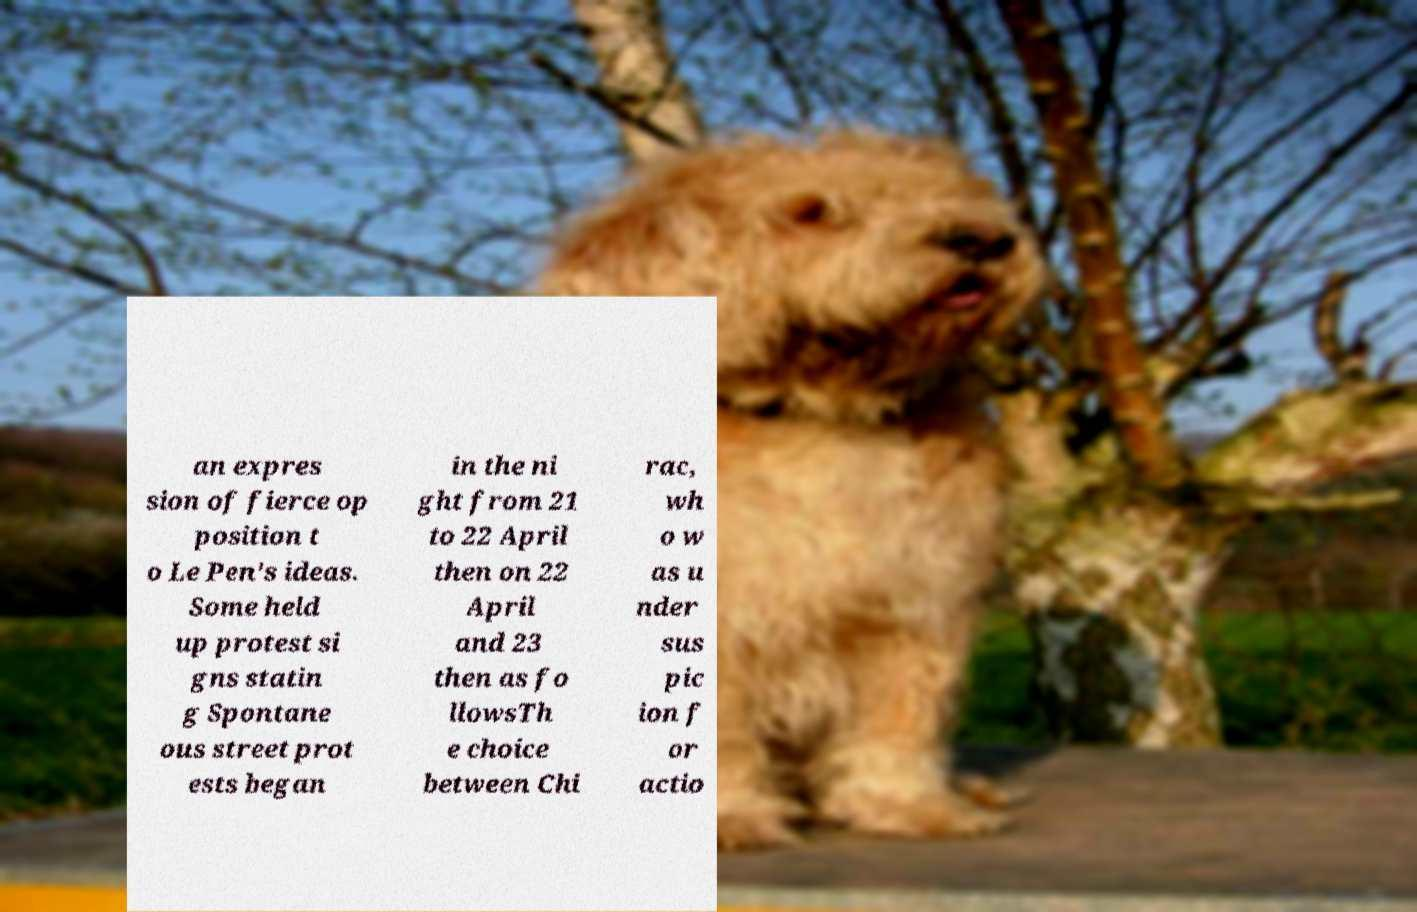Please read and relay the text visible in this image. What does it say? an expres sion of fierce op position t o Le Pen's ideas. Some held up protest si gns statin g Spontane ous street prot ests began in the ni ght from 21 to 22 April then on 22 April and 23 then as fo llowsTh e choice between Chi rac, wh o w as u nder sus pic ion f or actio 